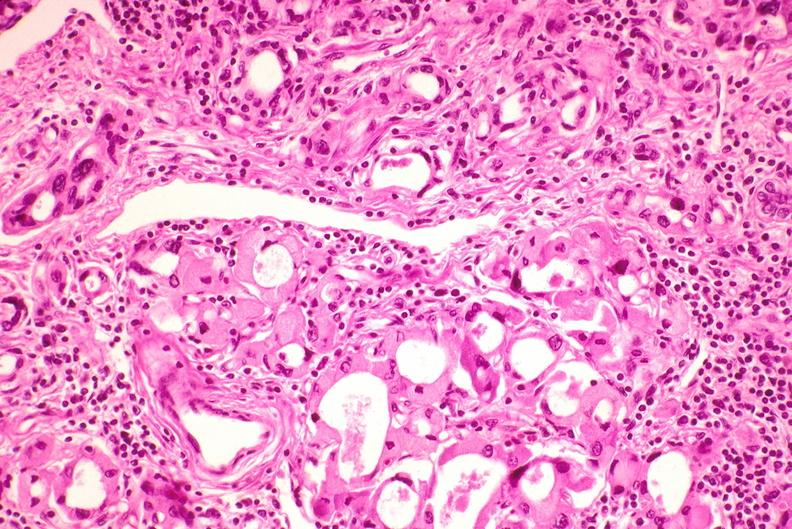does conjoined twins show thyroid, hashimoto 's?
Answer the question using a single word or phrase. No 